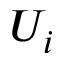Convert formula to latex. <formula><loc_0><loc_0><loc_500><loc_500>U _ { i }</formula> 